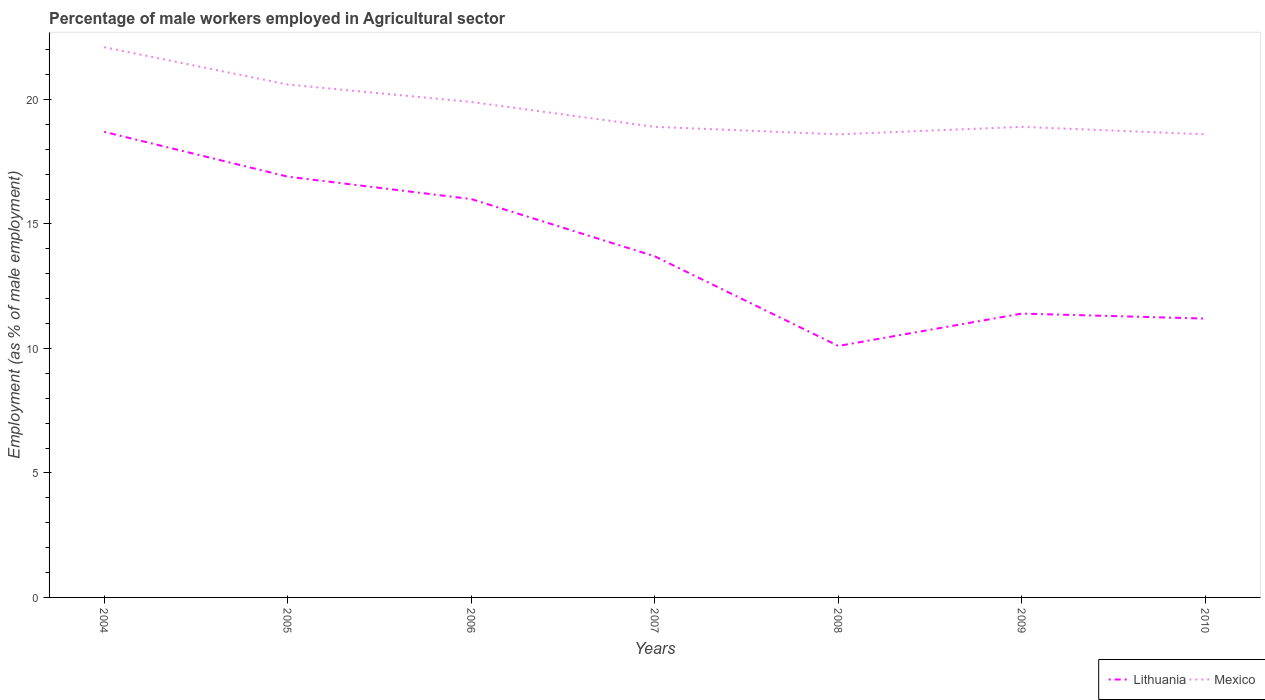Across all years, what is the maximum percentage of male workers employed in Agricultural sector in Mexico?
Keep it short and to the point. 18.6. In which year was the percentage of male workers employed in Agricultural sector in Lithuania maximum?
Provide a short and direct response. 2008. What is the total percentage of male workers employed in Agricultural sector in Lithuania in the graph?
Keep it short and to the point. 8.6. What is the difference between the highest and the second highest percentage of male workers employed in Agricultural sector in Lithuania?
Offer a very short reply. 8.6. What is the difference between the highest and the lowest percentage of male workers employed in Agricultural sector in Mexico?
Provide a short and direct response. 3. Is the percentage of male workers employed in Agricultural sector in Mexico strictly greater than the percentage of male workers employed in Agricultural sector in Lithuania over the years?
Provide a succinct answer. No. How many years are there in the graph?
Keep it short and to the point. 7. Are the values on the major ticks of Y-axis written in scientific E-notation?
Keep it short and to the point. No. What is the title of the graph?
Your response must be concise. Percentage of male workers employed in Agricultural sector. What is the label or title of the X-axis?
Provide a short and direct response. Years. What is the label or title of the Y-axis?
Your answer should be compact. Employment (as % of male employment). What is the Employment (as % of male employment) of Lithuania in 2004?
Keep it short and to the point. 18.7. What is the Employment (as % of male employment) of Mexico in 2004?
Provide a succinct answer. 22.1. What is the Employment (as % of male employment) of Lithuania in 2005?
Offer a terse response. 16.9. What is the Employment (as % of male employment) of Mexico in 2005?
Keep it short and to the point. 20.6. What is the Employment (as % of male employment) of Lithuania in 2006?
Your response must be concise. 16. What is the Employment (as % of male employment) of Mexico in 2006?
Provide a short and direct response. 19.9. What is the Employment (as % of male employment) in Lithuania in 2007?
Provide a short and direct response. 13.7. What is the Employment (as % of male employment) in Mexico in 2007?
Provide a short and direct response. 18.9. What is the Employment (as % of male employment) of Lithuania in 2008?
Provide a succinct answer. 10.1. What is the Employment (as % of male employment) in Mexico in 2008?
Give a very brief answer. 18.6. What is the Employment (as % of male employment) in Lithuania in 2009?
Your answer should be compact. 11.4. What is the Employment (as % of male employment) of Mexico in 2009?
Give a very brief answer. 18.9. What is the Employment (as % of male employment) in Lithuania in 2010?
Provide a short and direct response. 11.2. What is the Employment (as % of male employment) in Mexico in 2010?
Offer a very short reply. 18.6. Across all years, what is the maximum Employment (as % of male employment) of Lithuania?
Your answer should be compact. 18.7. Across all years, what is the maximum Employment (as % of male employment) of Mexico?
Give a very brief answer. 22.1. Across all years, what is the minimum Employment (as % of male employment) in Lithuania?
Make the answer very short. 10.1. Across all years, what is the minimum Employment (as % of male employment) of Mexico?
Offer a terse response. 18.6. What is the total Employment (as % of male employment) in Lithuania in the graph?
Provide a short and direct response. 98. What is the total Employment (as % of male employment) of Mexico in the graph?
Your response must be concise. 137.6. What is the difference between the Employment (as % of male employment) of Lithuania in 2004 and that in 2006?
Provide a succinct answer. 2.7. What is the difference between the Employment (as % of male employment) in Mexico in 2004 and that in 2006?
Your answer should be compact. 2.2. What is the difference between the Employment (as % of male employment) in Lithuania in 2004 and that in 2007?
Your response must be concise. 5. What is the difference between the Employment (as % of male employment) of Mexico in 2004 and that in 2007?
Offer a terse response. 3.2. What is the difference between the Employment (as % of male employment) of Mexico in 2004 and that in 2008?
Ensure brevity in your answer.  3.5. What is the difference between the Employment (as % of male employment) of Lithuania in 2004 and that in 2009?
Offer a very short reply. 7.3. What is the difference between the Employment (as % of male employment) of Lithuania in 2005 and that in 2007?
Make the answer very short. 3.2. What is the difference between the Employment (as % of male employment) of Mexico in 2005 and that in 2008?
Your answer should be compact. 2. What is the difference between the Employment (as % of male employment) of Lithuania in 2005 and that in 2009?
Offer a terse response. 5.5. What is the difference between the Employment (as % of male employment) of Lithuania in 2005 and that in 2010?
Keep it short and to the point. 5.7. What is the difference between the Employment (as % of male employment) in Lithuania in 2006 and that in 2009?
Give a very brief answer. 4.6. What is the difference between the Employment (as % of male employment) in Lithuania in 2007 and that in 2008?
Ensure brevity in your answer.  3.6. What is the difference between the Employment (as % of male employment) of Mexico in 2007 and that in 2008?
Your response must be concise. 0.3. What is the difference between the Employment (as % of male employment) in Lithuania in 2007 and that in 2009?
Offer a terse response. 2.3. What is the difference between the Employment (as % of male employment) of Lithuania in 2007 and that in 2010?
Your answer should be compact. 2.5. What is the difference between the Employment (as % of male employment) in Mexico in 2007 and that in 2010?
Offer a very short reply. 0.3. What is the difference between the Employment (as % of male employment) of Mexico in 2008 and that in 2009?
Provide a short and direct response. -0.3. What is the difference between the Employment (as % of male employment) of Lithuania in 2008 and that in 2010?
Ensure brevity in your answer.  -1.1. What is the difference between the Employment (as % of male employment) in Mexico in 2009 and that in 2010?
Your response must be concise. 0.3. What is the difference between the Employment (as % of male employment) of Lithuania in 2004 and the Employment (as % of male employment) of Mexico in 2005?
Your answer should be compact. -1.9. What is the difference between the Employment (as % of male employment) in Lithuania in 2004 and the Employment (as % of male employment) in Mexico in 2007?
Make the answer very short. -0.2. What is the difference between the Employment (as % of male employment) of Lithuania in 2004 and the Employment (as % of male employment) of Mexico in 2009?
Your response must be concise. -0.2. What is the difference between the Employment (as % of male employment) in Lithuania in 2005 and the Employment (as % of male employment) in Mexico in 2006?
Give a very brief answer. -3. What is the difference between the Employment (as % of male employment) in Lithuania in 2006 and the Employment (as % of male employment) in Mexico in 2007?
Offer a terse response. -2.9. What is the difference between the Employment (as % of male employment) of Lithuania in 2006 and the Employment (as % of male employment) of Mexico in 2008?
Provide a succinct answer. -2.6. What is the difference between the Employment (as % of male employment) of Lithuania in 2007 and the Employment (as % of male employment) of Mexico in 2010?
Give a very brief answer. -4.9. What is the difference between the Employment (as % of male employment) of Lithuania in 2009 and the Employment (as % of male employment) of Mexico in 2010?
Your answer should be compact. -7.2. What is the average Employment (as % of male employment) of Mexico per year?
Provide a short and direct response. 19.66. In the year 2008, what is the difference between the Employment (as % of male employment) in Lithuania and Employment (as % of male employment) in Mexico?
Provide a succinct answer. -8.5. In the year 2010, what is the difference between the Employment (as % of male employment) of Lithuania and Employment (as % of male employment) of Mexico?
Keep it short and to the point. -7.4. What is the ratio of the Employment (as % of male employment) of Lithuania in 2004 to that in 2005?
Your answer should be very brief. 1.11. What is the ratio of the Employment (as % of male employment) in Mexico in 2004 to that in 2005?
Ensure brevity in your answer.  1.07. What is the ratio of the Employment (as % of male employment) of Lithuania in 2004 to that in 2006?
Offer a terse response. 1.17. What is the ratio of the Employment (as % of male employment) of Mexico in 2004 to that in 2006?
Give a very brief answer. 1.11. What is the ratio of the Employment (as % of male employment) in Lithuania in 2004 to that in 2007?
Keep it short and to the point. 1.36. What is the ratio of the Employment (as % of male employment) in Mexico in 2004 to that in 2007?
Provide a short and direct response. 1.17. What is the ratio of the Employment (as % of male employment) in Lithuania in 2004 to that in 2008?
Offer a terse response. 1.85. What is the ratio of the Employment (as % of male employment) of Mexico in 2004 to that in 2008?
Your answer should be very brief. 1.19. What is the ratio of the Employment (as % of male employment) in Lithuania in 2004 to that in 2009?
Provide a short and direct response. 1.64. What is the ratio of the Employment (as % of male employment) in Mexico in 2004 to that in 2009?
Offer a terse response. 1.17. What is the ratio of the Employment (as % of male employment) in Lithuania in 2004 to that in 2010?
Keep it short and to the point. 1.67. What is the ratio of the Employment (as % of male employment) of Mexico in 2004 to that in 2010?
Offer a terse response. 1.19. What is the ratio of the Employment (as % of male employment) of Lithuania in 2005 to that in 2006?
Your answer should be very brief. 1.06. What is the ratio of the Employment (as % of male employment) of Mexico in 2005 to that in 2006?
Your answer should be very brief. 1.04. What is the ratio of the Employment (as % of male employment) in Lithuania in 2005 to that in 2007?
Your response must be concise. 1.23. What is the ratio of the Employment (as % of male employment) of Mexico in 2005 to that in 2007?
Provide a succinct answer. 1.09. What is the ratio of the Employment (as % of male employment) in Lithuania in 2005 to that in 2008?
Provide a succinct answer. 1.67. What is the ratio of the Employment (as % of male employment) in Mexico in 2005 to that in 2008?
Offer a very short reply. 1.11. What is the ratio of the Employment (as % of male employment) in Lithuania in 2005 to that in 2009?
Offer a very short reply. 1.48. What is the ratio of the Employment (as % of male employment) in Mexico in 2005 to that in 2009?
Your response must be concise. 1.09. What is the ratio of the Employment (as % of male employment) in Lithuania in 2005 to that in 2010?
Make the answer very short. 1.51. What is the ratio of the Employment (as % of male employment) in Mexico in 2005 to that in 2010?
Your response must be concise. 1.11. What is the ratio of the Employment (as % of male employment) in Lithuania in 2006 to that in 2007?
Your answer should be very brief. 1.17. What is the ratio of the Employment (as % of male employment) in Mexico in 2006 to that in 2007?
Provide a succinct answer. 1.05. What is the ratio of the Employment (as % of male employment) of Lithuania in 2006 to that in 2008?
Your answer should be compact. 1.58. What is the ratio of the Employment (as % of male employment) in Mexico in 2006 to that in 2008?
Provide a succinct answer. 1.07. What is the ratio of the Employment (as % of male employment) of Lithuania in 2006 to that in 2009?
Provide a short and direct response. 1.4. What is the ratio of the Employment (as % of male employment) in Mexico in 2006 to that in 2009?
Your answer should be very brief. 1.05. What is the ratio of the Employment (as % of male employment) in Lithuania in 2006 to that in 2010?
Make the answer very short. 1.43. What is the ratio of the Employment (as % of male employment) of Mexico in 2006 to that in 2010?
Offer a very short reply. 1.07. What is the ratio of the Employment (as % of male employment) of Lithuania in 2007 to that in 2008?
Ensure brevity in your answer.  1.36. What is the ratio of the Employment (as % of male employment) of Mexico in 2007 to that in 2008?
Ensure brevity in your answer.  1.02. What is the ratio of the Employment (as % of male employment) of Lithuania in 2007 to that in 2009?
Your response must be concise. 1.2. What is the ratio of the Employment (as % of male employment) of Mexico in 2007 to that in 2009?
Make the answer very short. 1. What is the ratio of the Employment (as % of male employment) in Lithuania in 2007 to that in 2010?
Your answer should be very brief. 1.22. What is the ratio of the Employment (as % of male employment) in Mexico in 2007 to that in 2010?
Provide a succinct answer. 1.02. What is the ratio of the Employment (as % of male employment) in Lithuania in 2008 to that in 2009?
Provide a succinct answer. 0.89. What is the ratio of the Employment (as % of male employment) of Mexico in 2008 to that in 2009?
Offer a terse response. 0.98. What is the ratio of the Employment (as % of male employment) in Lithuania in 2008 to that in 2010?
Keep it short and to the point. 0.9. What is the ratio of the Employment (as % of male employment) of Mexico in 2008 to that in 2010?
Your response must be concise. 1. What is the ratio of the Employment (as % of male employment) in Lithuania in 2009 to that in 2010?
Make the answer very short. 1.02. What is the ratio of the Employment (as % of male employment) in Mexico in 2009 to that in 2010?
Make the answer very short. 1.02. What is the difference between the highest and the second highest Employment (as % of male employment) of Lithuania?
Offer a terse response. 1.8. What is the difference between the highest and the second highest Employment (as % of male employment) of Mexico?
Give a very brief answer. 1.5. What is the difference between the highest and the lowest Employment (as % of male employment) in Lithuania?
Ensure brevity in your answer.  8.6. 